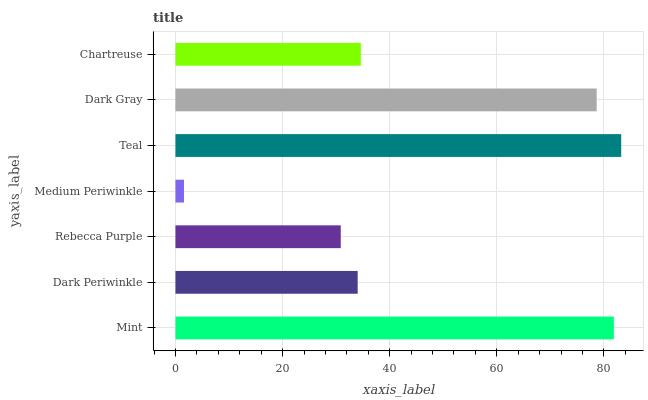Is Medium Periwinkle the minimum?
Answer yes or no. Yes. Is Teal the maximum?
Answer yes or no. Yes. Is Dark Periwinkle the minimum?
Answer yes or no. No. Is Dark Periwinkle the maximum?
Answer yes or no. No. Is Mint greater than Dark Periwinkle?
Answer yes or no. Yes. Is Dark Periwinkle less than Mint?
Answer yes or no. Yes. Is Dark Periwinkle greater than Mint?
Answer yes or no. No. Is Mint less than Dark Periwinkle?
Answer yes or no. No. Is Chartreuse the high median?
Answer yes or no. Yes. Is Chartreuse the low median?
Answer yes or no. Yes. Is Rebecca Purple the high median?
Answer yes or no. No. Is Teal the low median?
Answer yes or no. No. 